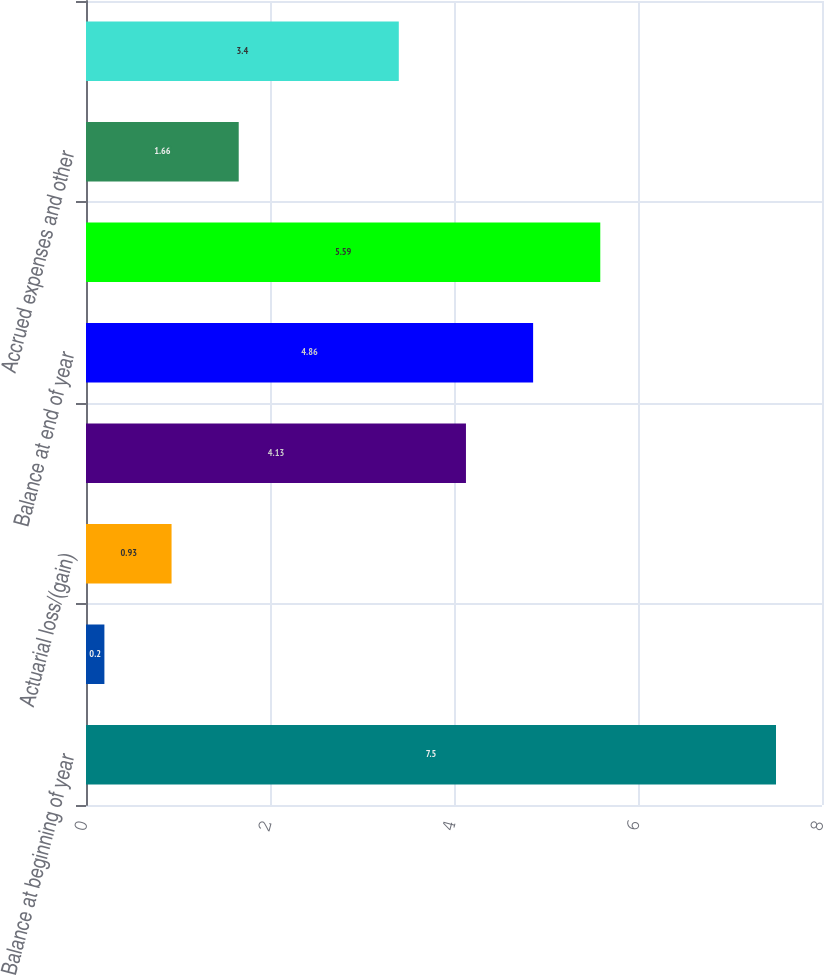Convert chart to OTSL. <chart><loc_0><loc_0><loc_500><loc_500><bar_chart><fcel>Balance at beginning of year<fcel>Interest cost<fcel>Actuarial loss/(gain)<fcel>Gross benefits paid<fcel>Balance at end of year<fcel>Funded status<fcel>Accrued expenses and other<fcel>Other liabilities<nl><fcel>7.5<fcel>0.2<fcel>0.93<fcel>4.13<fcel>4.86<fcel>5.59<fcel>1.66<fcel>3.4<nl></chart> 